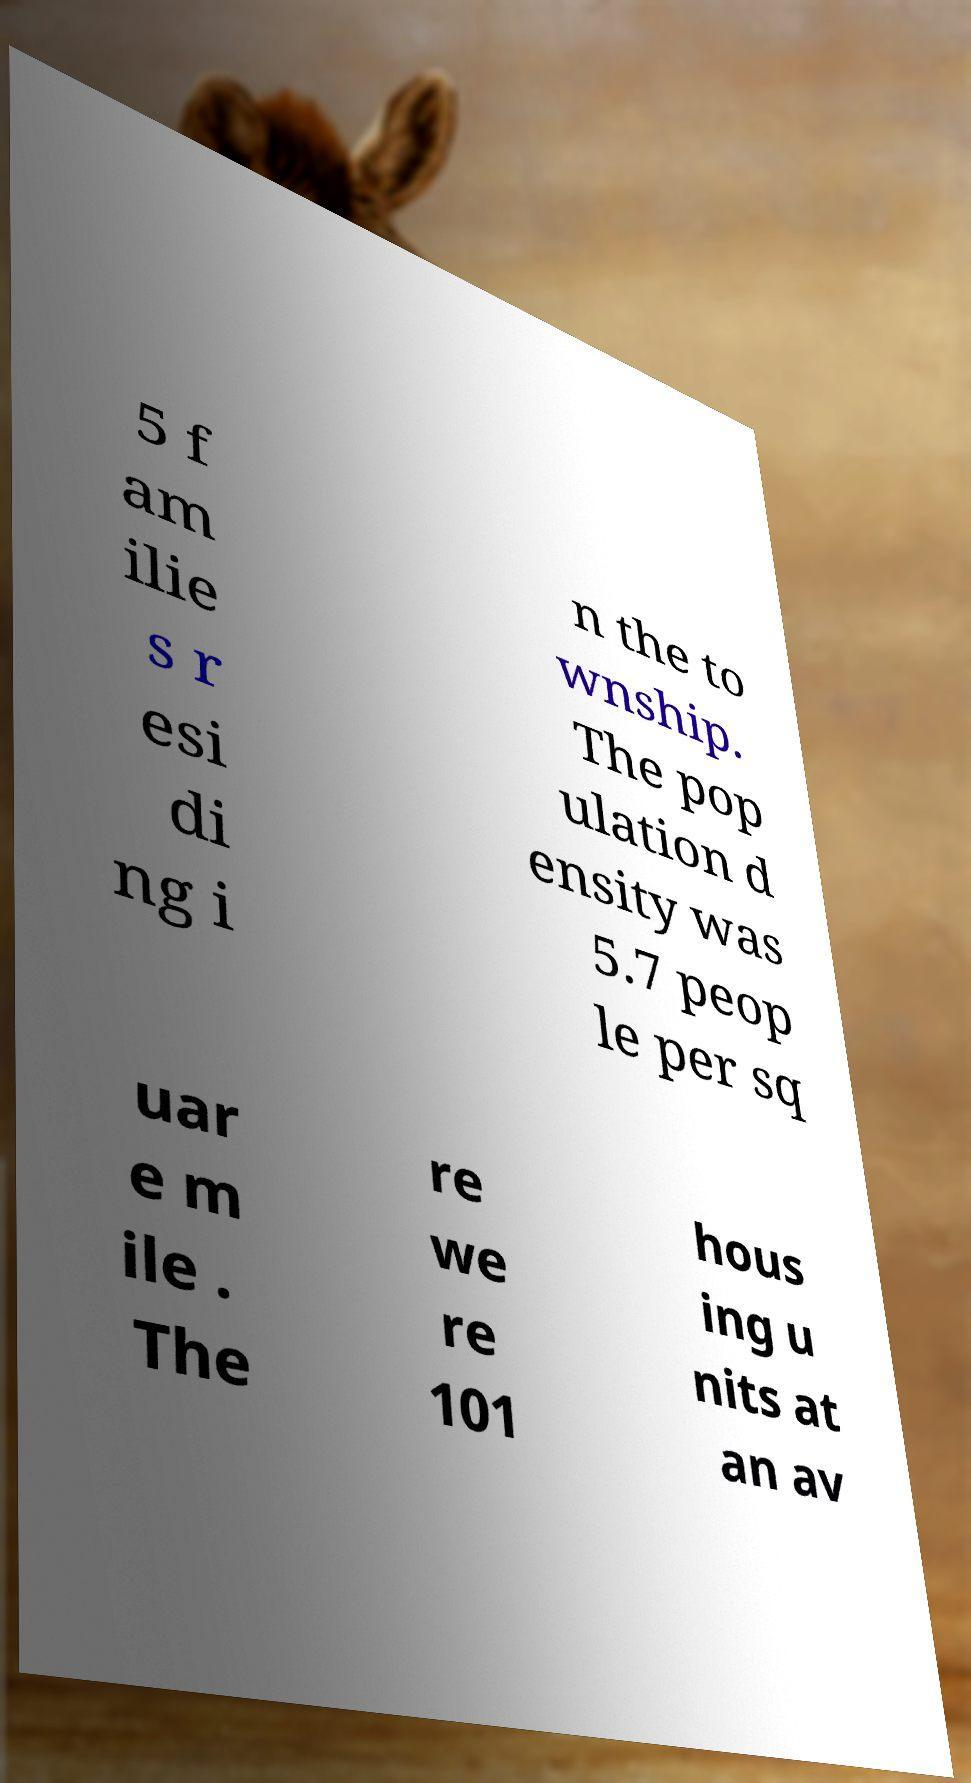What messages or text are displayed in this image? I need them in a readable, typed format. 5 f am ilie s r esi di ng i n the to wnship. The pop ulation d ensity was 5.7 peop le per sq uar e m ile . The re we re 101 hous ing u nits at an av 